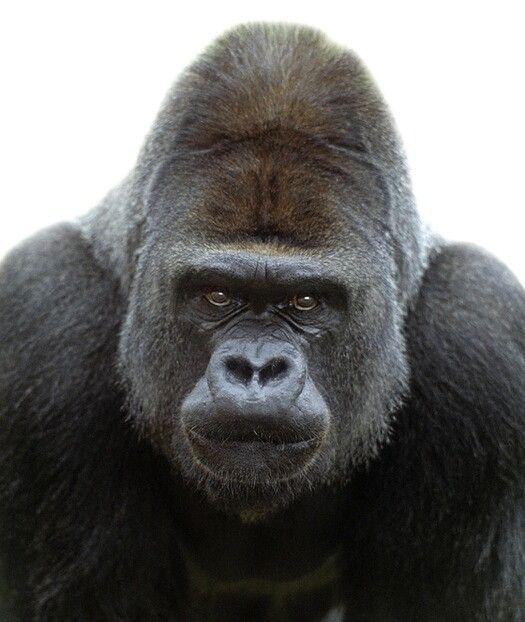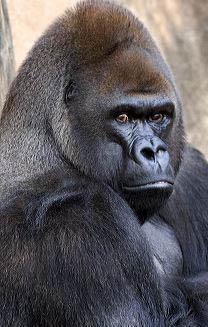The first image is the image on the left, the second image is the image on the right. Analyze the images presented: Is the assertion "In at least one image there is a gorilla with his mouth wide open." valid? Answer yes or no. No. The first image is the image on the left, the second image is the image on the right. Assess this claim about the two images: "An ape has its mouth open.". Correct or not? Answer yes or no. No. 